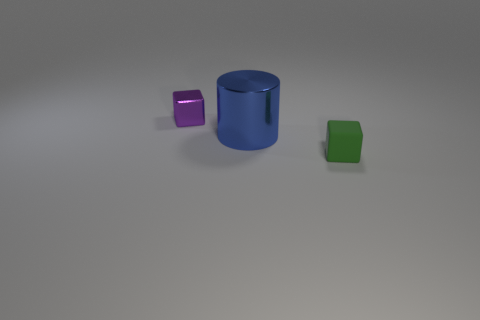There is a green matte object that is in front of the purple thing; is it the same size as the metallic object that is in front of the small purple shiny block?
Offer a terse response. No. There is a blue metal cylinder; is it the same size as the object that is behind the large thing?
Offer a terse response. No. There is a metal thing in front of the tiny object that is left of the tiny green object; how big is it?
Offer a terse response. Large. What is the color of the other tiny thing that is the same shape as the small rubber thing?
Your answer should be compact. Purple. Is the blue metal object the same size as the rubber object?
Provide a succinct answer. No. Is the number of cubes on the left side of the tiny green object the same as the number of small metal cubes?
Give a very brief answer. Yes. Is there a small green object on the left side of the small thing that is to the right of the purple thing?
Offer a very short reply. No. There is a cube left of the green rubber object in front of the shiny object on the right side of the purple metal cube; how big is it?
Provide a short and direct response. Small. What is the material of the small cube that is behind the tiny cube in front of the shiny cylinder?
Provide a succinct answer. Metal. Are there any other tiny rubber things that have the same shape as the small purple object?
Give a very brief answer. Yes. 